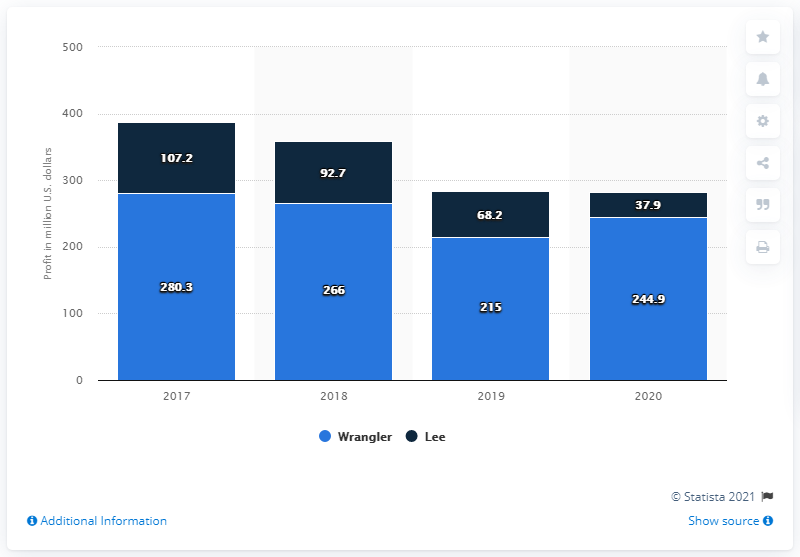How much money did the Wrangler brand make in the U.S. in 2020?
 244.9 